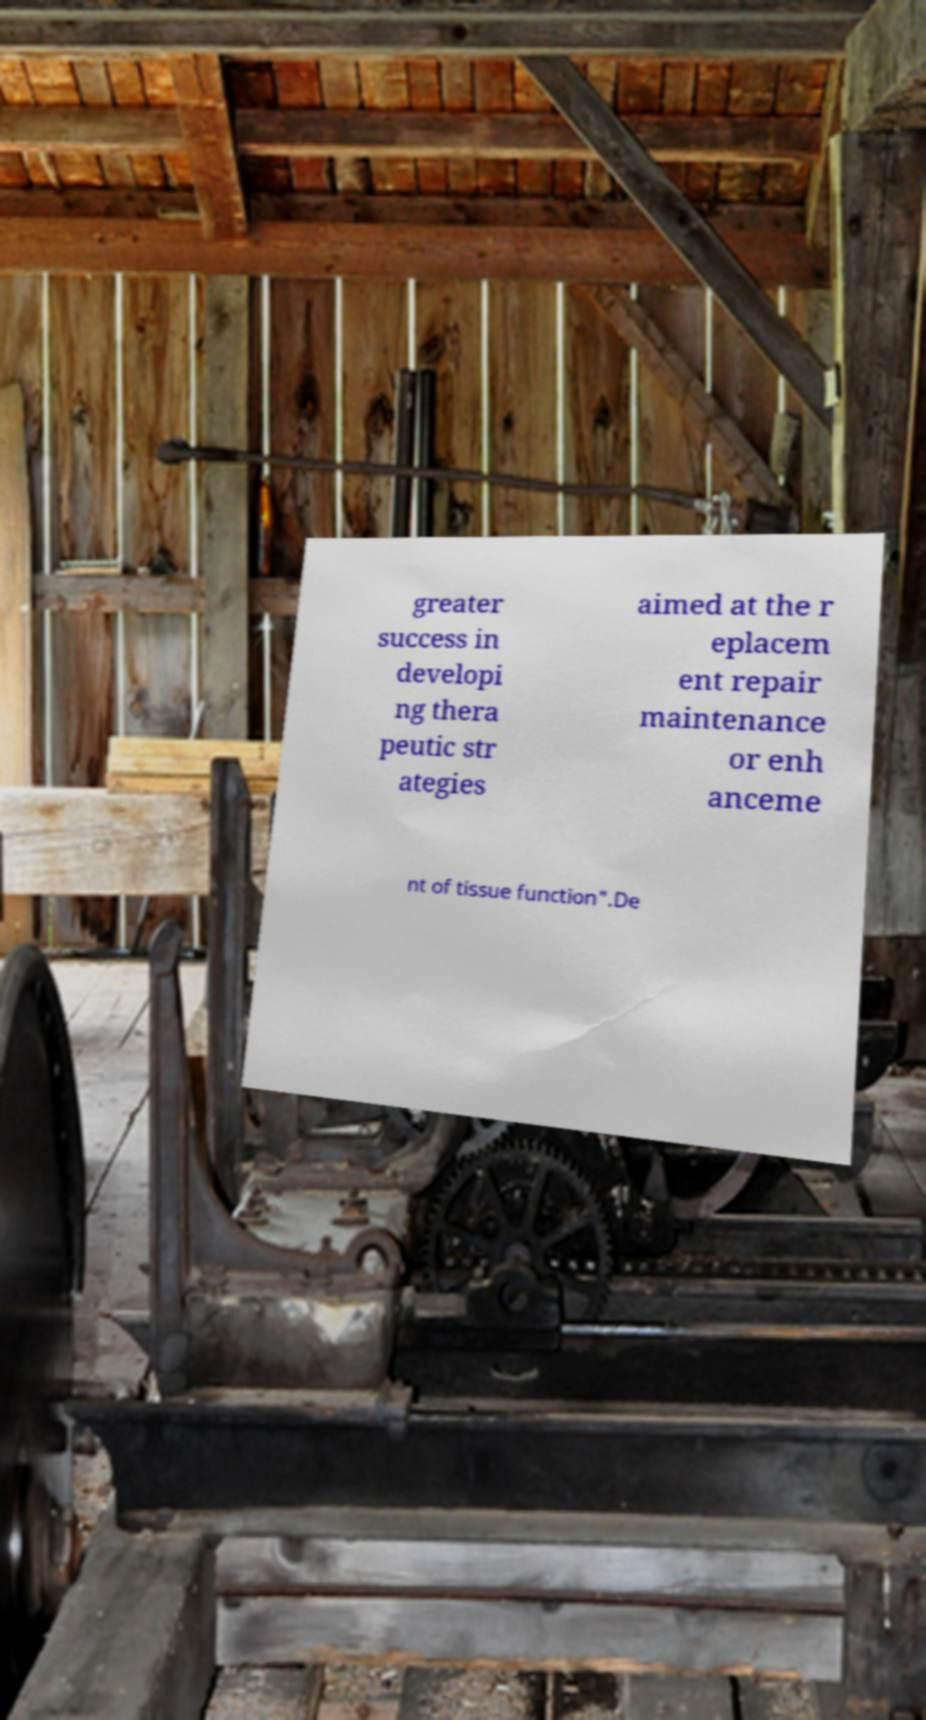Please read and relay the text visible in this image. What does it say? greater success in developi ng thera peutic str ategies aimed at the r eplacem ent repair maintenance or enh anceme nt of tissue function".De 